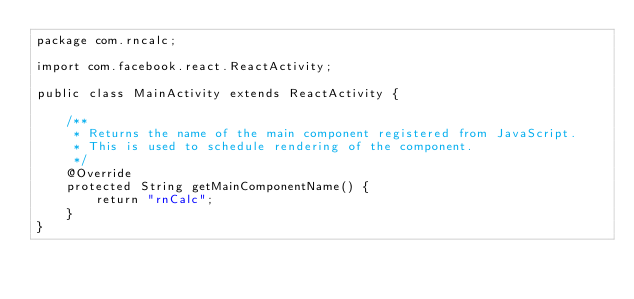<code> <loc_0><loc_0><loc_500><loc_500><_Java_>package com.rncalc;

import com.facebook.react.ReactActivity;

public class MainActivity extends ReactActivity {

    /**
     * Returns the name of the main component registered from JavaScript.
     * This is used to schedule rendering of the component.
     */
    @Override
    protected String getMainComponentName() {
        return "rnCalc";
    }
}
</code> 